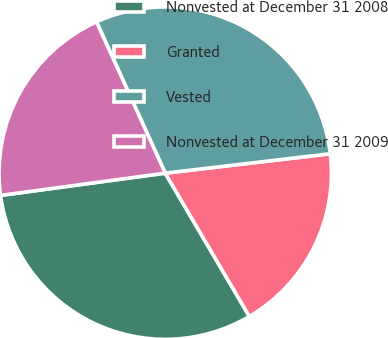<chart> <loc_0><loc_0><loc_500><loc_500><pie_chart><fcel>Nonvested at December 31 2008<fcel>Granted<fcel>Vested<fcel>Nonvested at December 31 2009<nl><fcel>31.31%<fcel>18.41%<fcel>29.93%<fcel>20.35%<nl></chart> 